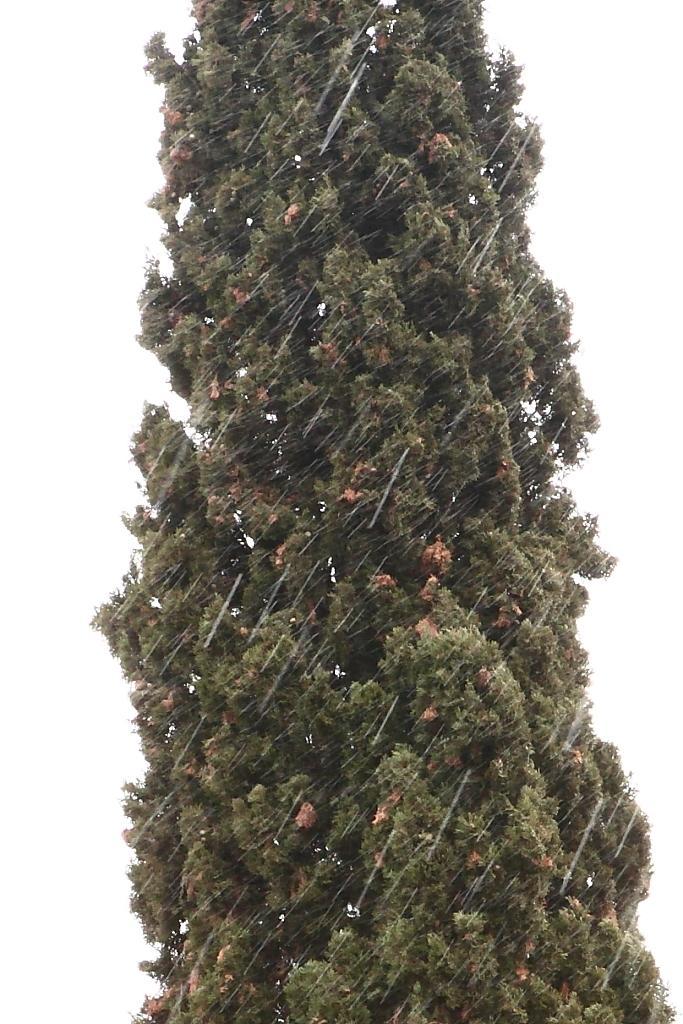Can you describe this image briefly? In this picture I can observe tree in the middle of the picture. The background is in white color. 